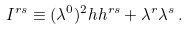Convert formula to latex. <formula><loc_0><loc_0><loc_500><loc_500>I ^ { r s } \equiv ( \lambda ^ { 0 } ) ^ { 2 } h h ^ { r s } + \lambda ^ { r } \lambda ^ { s } \, .</formula> 